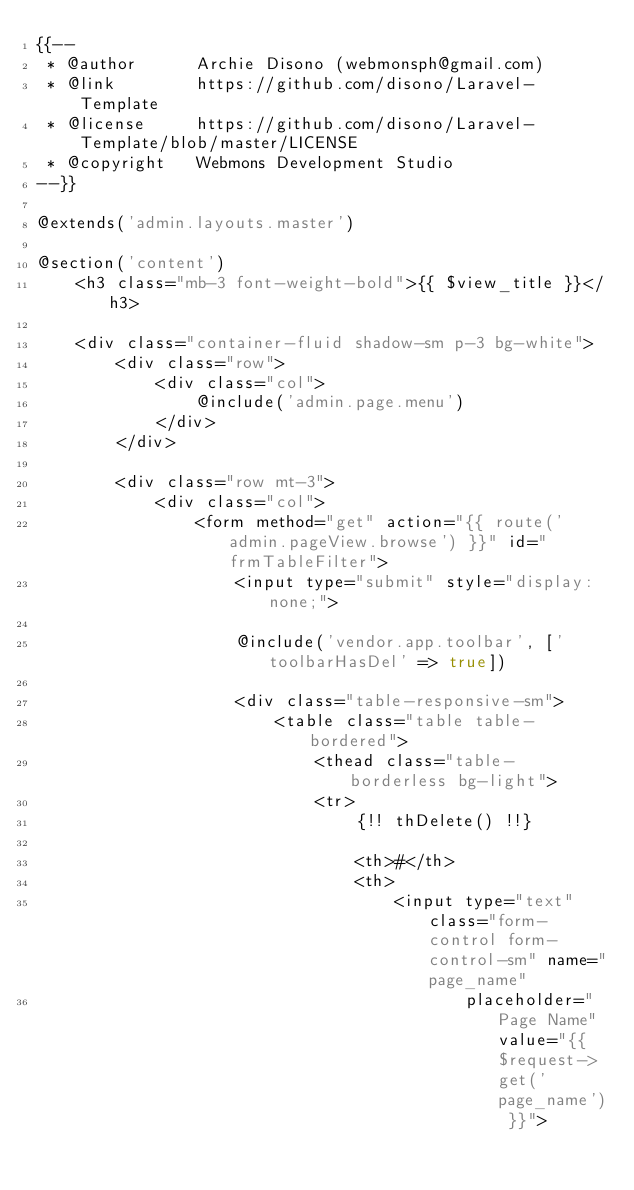<code> <loc_0><loc_0><loc_500><loc_500><_PHP_>{{--
 * @author      Archie Disono (webmonsph@gmail.com)
 * @link        https://github.com/disono/Laravel-Template
 * @license     https://github.com/disono/Laravel-Template/blob/master/LICENSE
 * @copyright   Webmons Development Studio
--}}

@extends('admin.layouts.master')

@section('content')
    <h3 class="mb-3 font-weight-bold">{{ $view_title }}</h3>

    <div class="container-fluid shadow-sm p-3 bg-white">
        <div class="row">
            <div class="col">
                @include('admin.page.menu')
            </div>
        </div>

        <div class="row mt-3">
            <div class="col">
                <form method="get" action="{{ route('admin.pageView.browse') }}" id="frmTableFilter">
                    <input type="submit" style="display: none;">

                    @include('vendor.app.toolbar', ['toolbarHasDel' => true])

                    <div class="table-responsive-sm">
                        <table class="table table-bordered">
                            <thead class="table-borderless bg-light">
                            <tr>
                                {!! thDelete() !!}

                                <th>#</th>
                                <th>
                                    <input type="text" class="form-control form-control-sm" name="page_name"
                                           placeholder="Page Name" value="{{ $request->get('page_name') }}"></code> 